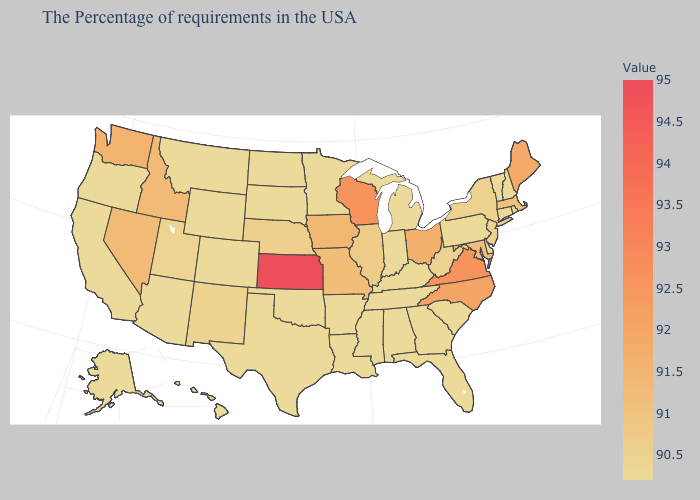Does Iowa have a higher value than Kentucky?
Short answer required. Yes. Does the map have missing data?
Short answer required. No. Among the states that border Illinois , which have the lowest value?
Answer briefly. Kentucky, Indiana. Does Virginia have the lowest value in the USA?
Quick response, please. No. Which states hav the highest value in the South?
Quick response, please. Virginia. 